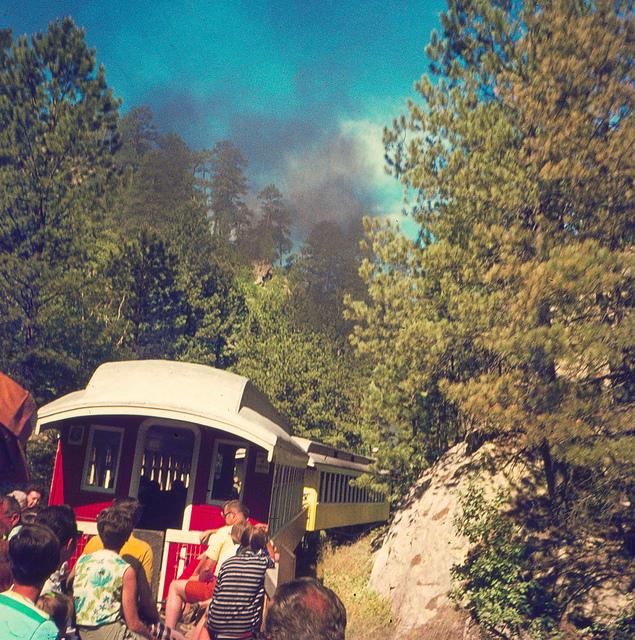Are there females on this group?
Quick response, please. Yes. How many cars do you see?
Write a very short answer. 2. Is something on fire?
Keep it brief. Yes. 